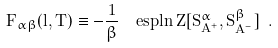<formula> <loc_0><loc_0><loc_500><loc_500>F _ { \alpha \beta } ( l , T ) \equiv - \frac { 1 } { \beta } \ \ e s p { \ln Z [ S ^ { \alpha } _ { A ^ { + } } , S ^ { \beta } _ { A ^ { - } } ] } \ .</formula> 